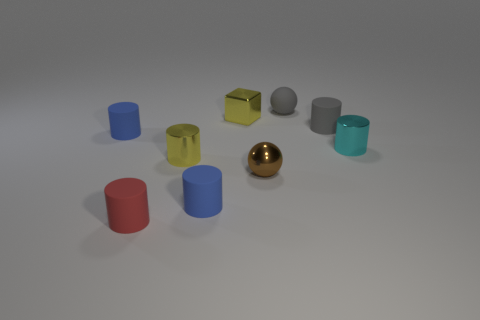Subtract 1 cylinders. How many cylinders are left? 5 Subtract all yellow cylinders. How many cylinders are left? 5 Subtract all shiny cylinders. How many cylinders are left? 4 Subtract all cyan cylinders. Subtract all gray blocks. How many cylinders are left? 5 Add 1 tiny cyan cylinders. How many objects exist? 10 Subtract all cylinders. How many objects are left? 3 Add 2 red metal cylinders. How many red metal cylinders exist? 2 Subtract 0 brown cylinders. How many objects are left? 9 Subtract all purple cylinders. Subtract all tiny red matte objects. How many objects are left? 8 Add 5 yellow objects. How many yellow objects are left? 7 